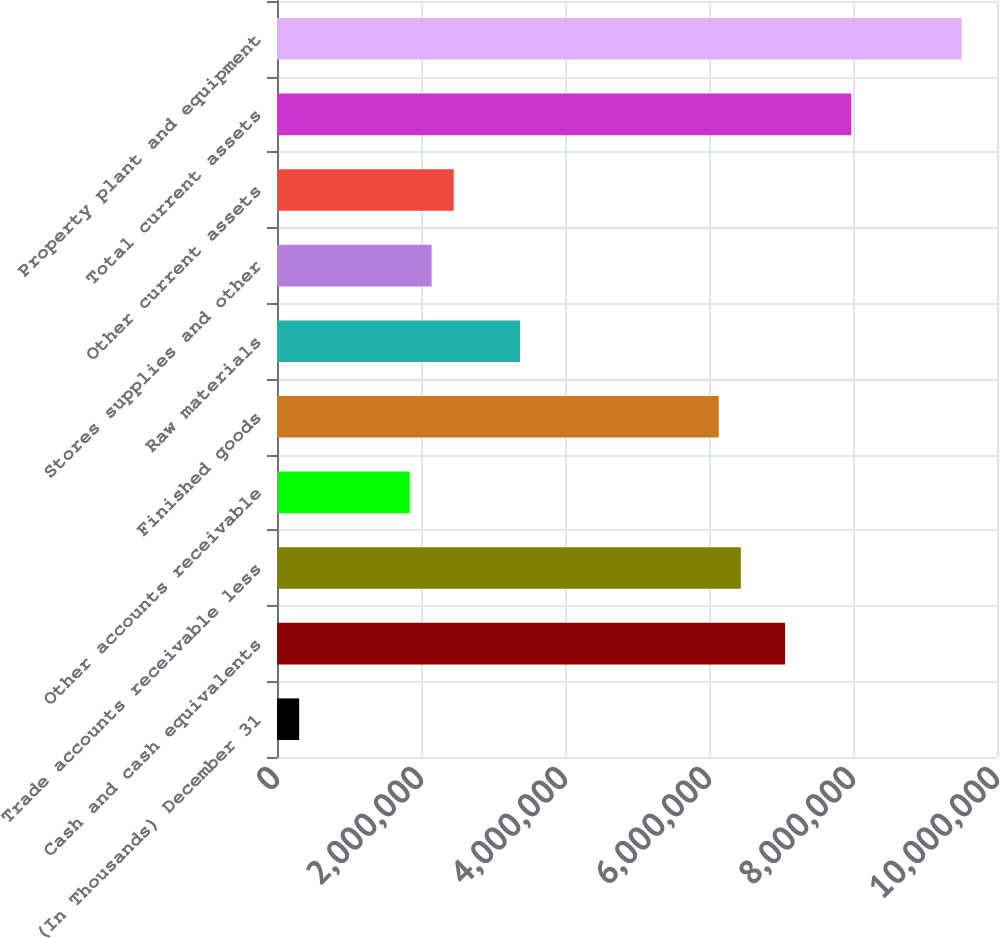Convert chart. <chart><loc_0><loc_0><loc_500><loc_500><bar_chart><fcel>(In Thousands) December 31<fcel>Cash and cash equivalents<fcel>Trade accounts receivable less<fcel>Other accounts receivable<fcel>Finished goods<fcel>Raw materials<fcel>Stores supplies and other<fcel>Other current assets<fcel>Total current assets<fcel>Property plant and equipment<nl><fcel>307632<fcel>7.0554e+06<fcel>6.44196e+06<fcel>1.84122e+06<fcel>6.13525e+06<fcel>3.3748e+06<fcel>2.14793e+06<fcel>2.45465e+06<fcel>7.97554e+06<fcel>9.50913e+06<nl></chart> 